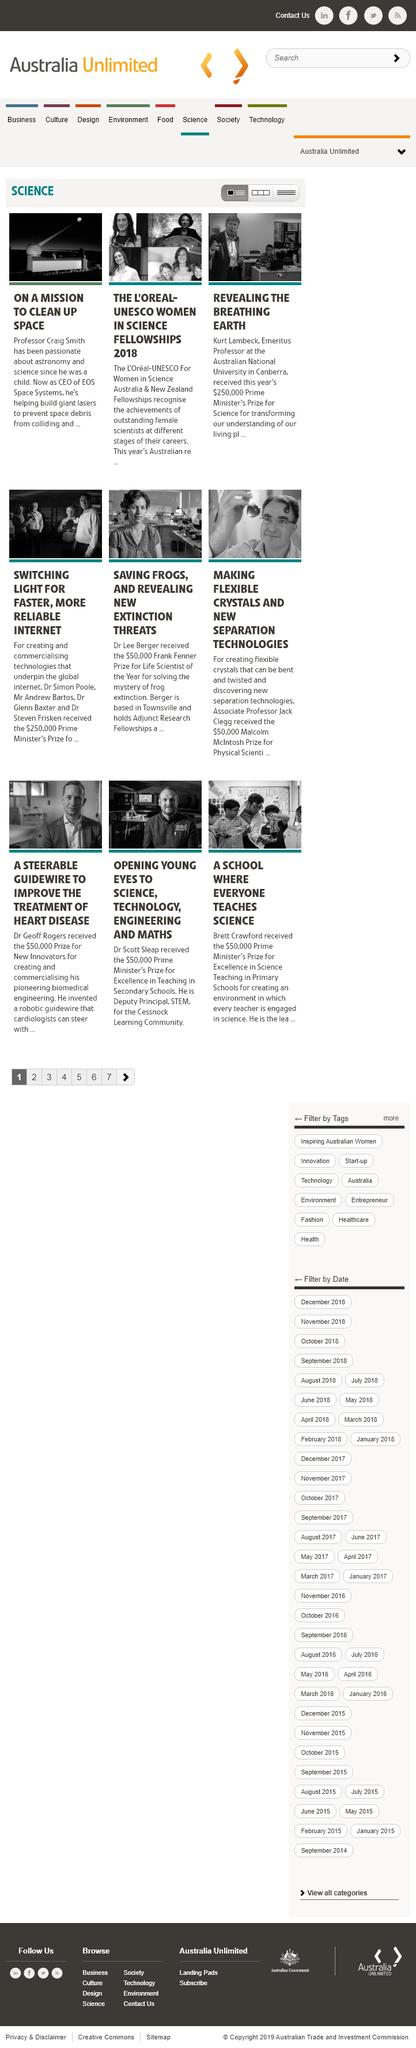Outline some significant characteristics in this image. The CEO of EOS is Professor Craig Smith. Kurt Lambeck has been credited with revealing the concept of the "breathing Earth. Kurt Lambeck was awarded $250,000. 